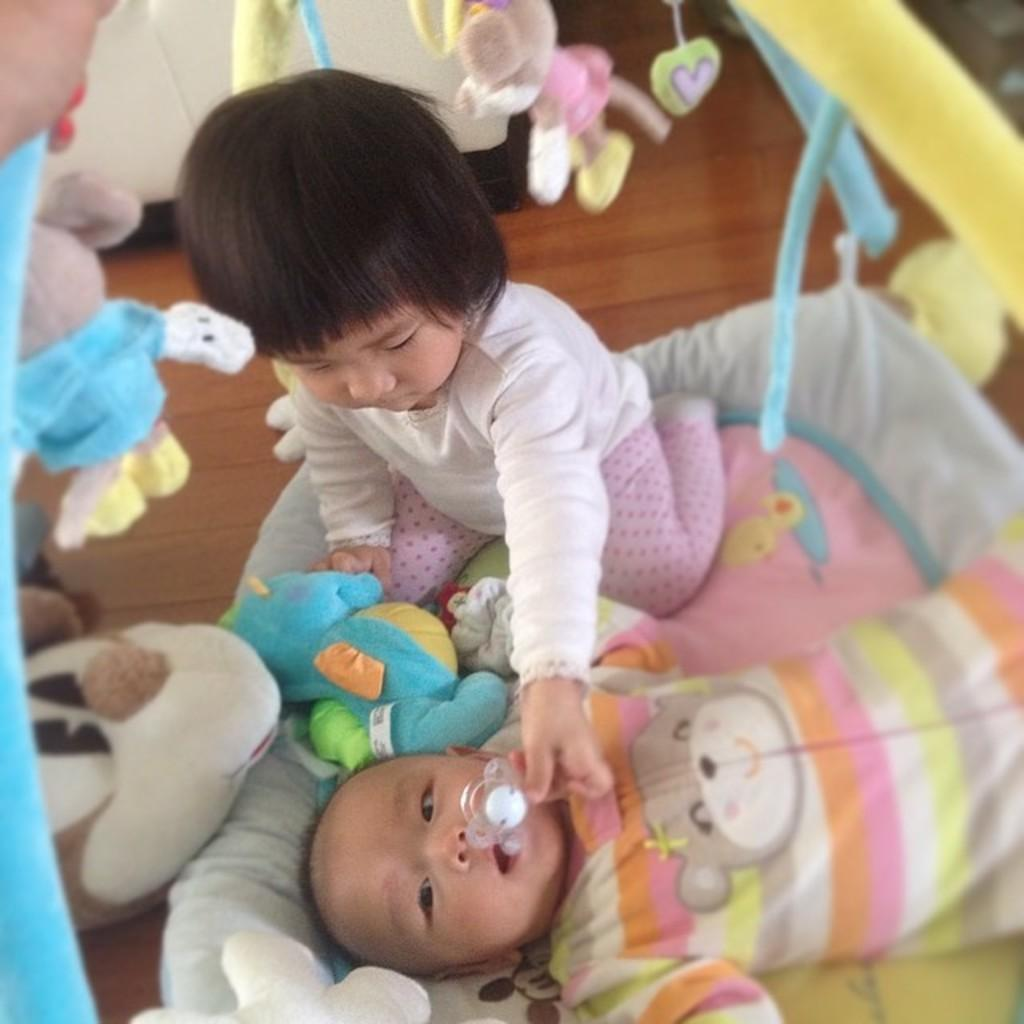What is the main subject in the foreground of the picture? There is a girl in the foreground of the picture. What else can be seen in the foreground of the picture? There is a baby on the bed in the foreground of the picture. What is hanging from the bed? Toys are hanging from the bed. What can be seen in the background of the picture? There is a floor visible in the background of the picture, and there is a cupboard in the background of the picture. What type of lip can be seen blowing the toys in the image? There is no lip present in the image, and the toys are hanging from the bed, not being blown. 